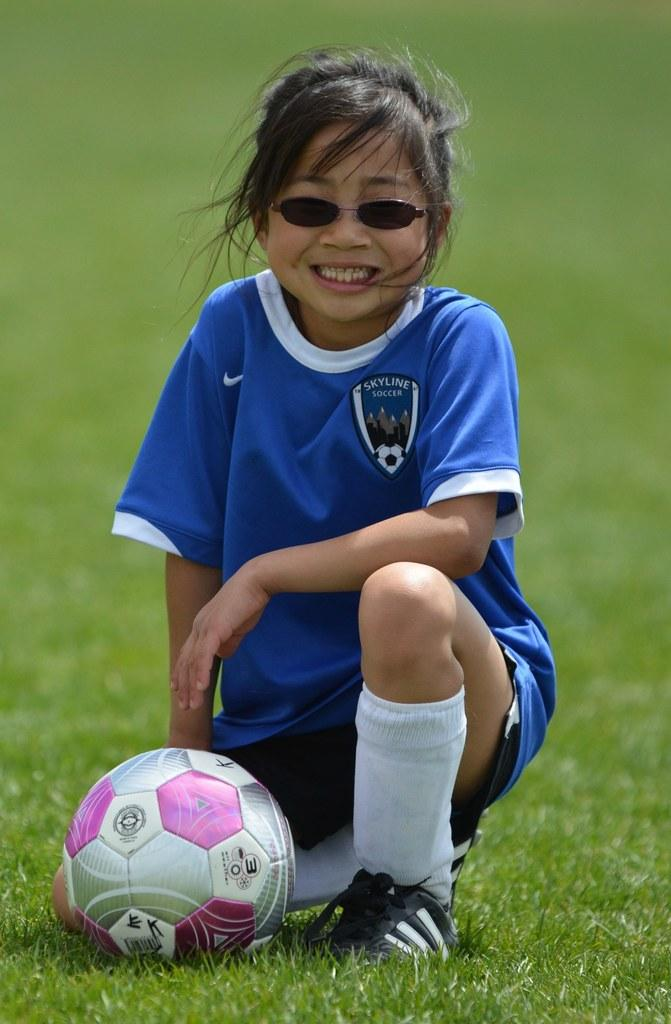What is the girl in the image doing? The girl is sitting in the image. What can be observed about the girl's appearance? The girl is wearing glasses. What is the girl's facial expression? The girl is smiling. What object is present on the grass in front of the girl? There is a ball on the grass in front of the girl. What type of coat is the girl wearing in the image? There is no coat visible in the image; the girl is wearing glasses and sitting on the grass. 